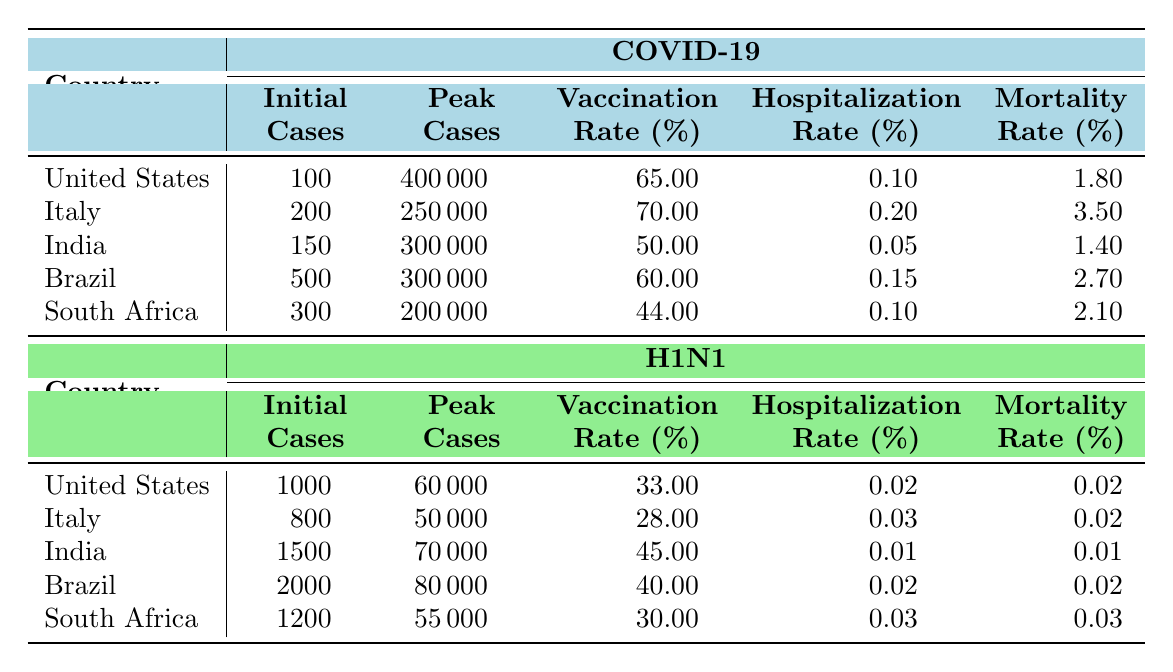What is the peak number of COVID-19 cases in the United States? The table indicates that the peak number of COVID-19 cases in the United States is listed as 400,000.
Answer: 400000 What is the vaccination rate for H1N1 in India? Based on the table, the vaccination rate for H1N1 in India is 45%.
Answer: 45 Which country has the highest hospitalization rate for COVID-19? From the table, Italy has the highest hospitalization rate for COVID-19 at 20%.
Answer: Italy Calculate the average mortality rate for COVID-19 across these countries. The mortality rates for COVID-19 are 1.8% (US), 3.5% (Italy), 1.4% (India), 2.7% (Brazil), and 2.1% (South Africa). Adding these rates gives 1.8 + 3.5 + 1.4 + 2.7 + 2.1 = 11.5%. Dividing by 5 yields an average of 11.5% / 5 = 2.3%.
Answer: 2.3 Is the initial number of cases for H1N1 in Brazil greater than that in South Africa? The table shows Brazil's initial cases for H1N1 at 2000, while South Africa's is 1200. Since 2000 is greater than 1200, the answer is yes.
Answer: Yes What is the difference in vaccination rates for COVID-19 between Italy and South Africa? The vaccination rate for COVID-19 in Italy is 70%, while in South Africa it is 44%. The difference is calculated as 70% - 44% = 26%.
Answer: 26 Which country showed the least initial cases for COVID-19? The table presents the initial COVID-19 cases as follows: 100 (US), 200 (Italy), 150 (India), 500 (Brazil), and 300 (South Africa). Among these, the least is 100 cases in the United States.
Answer: United States Was the peak number of H1N1 cases in the United States higher than that in India? The peak for H1N1 in the United States is 60,000, while in India it is 70,000. Since 60,000 is not greater than 70,000, the answer is no.
Answer: No What is the total number of initial cases reported for COVID-19 across all listed countries? Summing the initial cases: 100 (US) + 200 (Italy) + 150 (India) + 500 (Brazil) + 300 (South Africa) equals 1250.
Answer: 1250 Identify the country with the highest mortality rate for H1N1. Reviewing the H1N1 mortality rates: 0.02% (US), 0.02% (Italy), 0.01% (India), 0.02% (Brazil), and 0.03% (South Africa). South Africa has the highest rate at 0.03%.
Answer: South Africa 